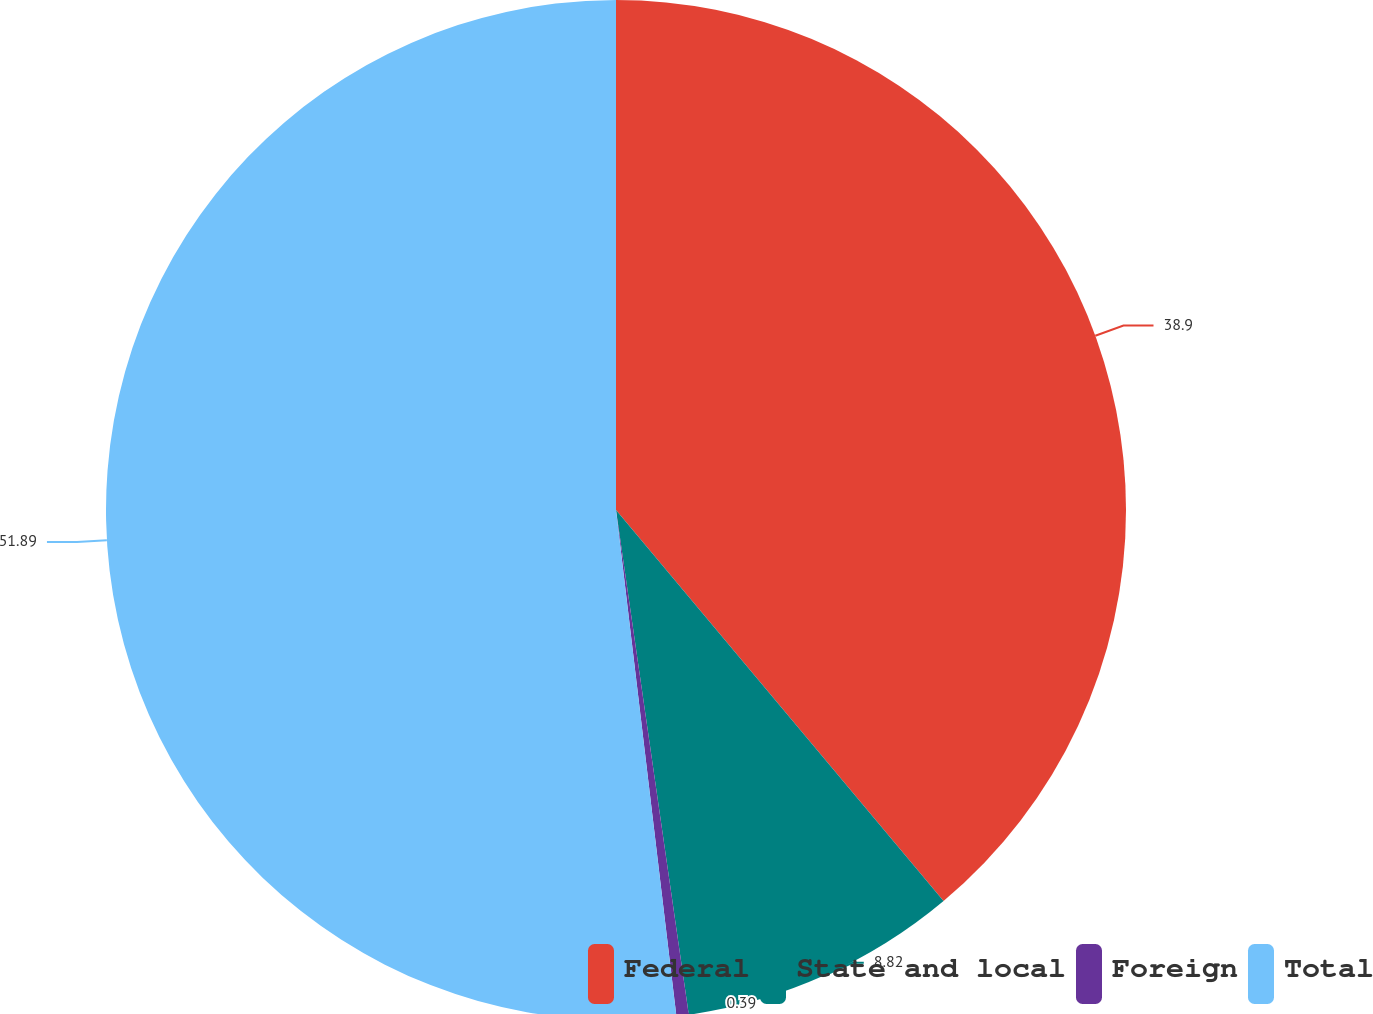Convert chart. <chart><loc_0><loc_0><loc_500><loc_500><pie_chart><fcel>Federal<fcel>State and local<fcel>Foreign<fcel>Total<nl><fcel>38.9%<fcel>8.82%<fcel>0.39%<fcel>51.89%<nl></chart> 